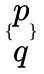Convert formula to latex. <formula><loc_0><loc_0><loc_500><loc_500>\{ \begin{matrix} p \\ q \end{matrix} \}</formula> 